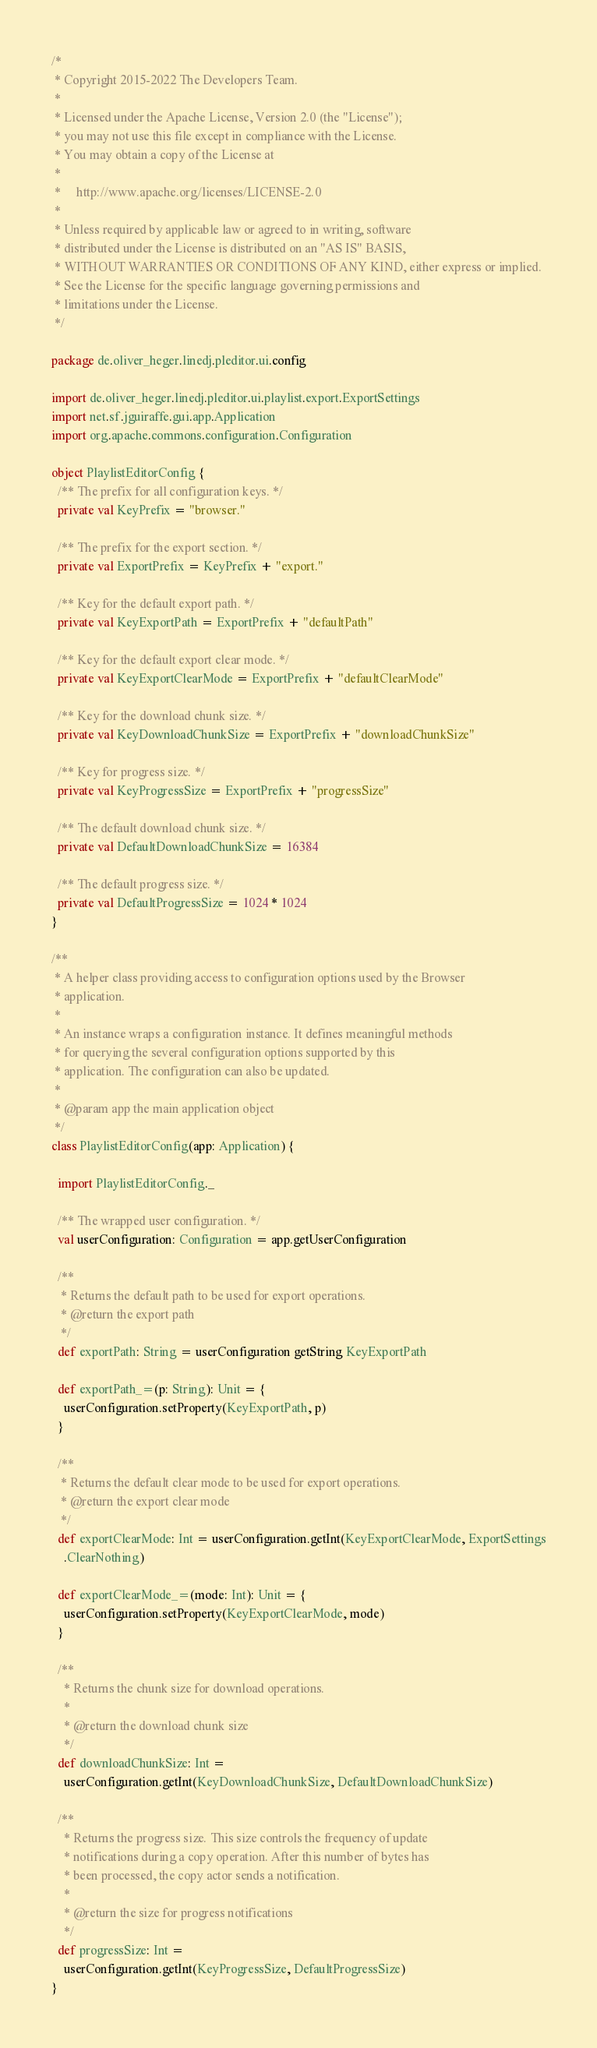<code> <loc_0><loc_0><loc_500><loc_500><_Scala_>/*
 * Copyright 2015-2022 The Developers Team.
 *
 * Licensed under the Apache License, Version 2.0 (the "License");
 * you may not use this file except in compliance with the License.
 * You may obtain a copy of the License at
 *
 *     http://www.apache.org/licenses/LICENSE-2.0
 *
 * Unless required by applicable law or agreed to in writing, software
 * distributed under the License is distributed on an "AS IS" BASIS,
 * WITHOUT WARRANTIES OR CONDITIONS OF ANY KIND, either express or implied.
 * See the License for the specific language governing permissions and
 * limitations under the License.
 */

package de.oliver_heger.linedj.pleditor.ui.config

import de.oliver_heger.linedj.pleditor.ui.playlist.export.ExportSettings
import net.sf.jguiraffe.gui.app.Application
import org.apache.commons.configuration.Configuration

object PlaylistEditorConfig {
  /** The prefix for all configuration keys. */
  private val KeyPrefix = "browser."

  /** The prefix for the export section. */
  private val ExportPrefix = KeyPrefix + "export."

  /** Key for the default export path. */
  private val KeyExportPath = ExportPrefix + "defaultPath"

  /** Key for the default export clear mode. */
  private val KeyExportClearMode = ExportPrefix + "defaultClearMode"

  /** Key for the download chunk size. */
  private val KeyDownloadChunkSize = ExportPrefix + "downloadChunkSize"

  /** Key for progress size. */
  private val KeyProgressSize = ExportPrefix + "progressSize"

  /** The default download chunk size. */
  private val DefaultDownloadChunkSize = 16384

  /** The default progress size. */
  private val DefaultProgressSize = 1024 * 1024
}

/**
 * A helper class providing access to configuration options used by the Browser
 * application.
 *
 * An instance wraps a configuration instance. It defines meaningful methods
 * for querying the several configuration options supported by this
 * application. The configuration can also be updated.
 *
 * @param app the main application object
 */
class PlaylistEditorConfig(app: Application) {

  import PlaylistEditorConfig._

  /** The wrapped user configuration. */
  val userConfiguration: Configuration = app.getUserConfiguration

  /**
   * Returns the default path to be used for export operations.
   * @return the export path
   */
  def exportPath: String = userConfiguration getString KeyExportPath

  def exportPath_=(p: String): Unit = {
    userConfiguration.setProperty(KeyExportPath, p)
  }

  /**
   * Returns the default clear mode to be used for export operations.
   * @return the export clear mode
   */
  def exportClearMode: Int = userConfiguration.getInt(KeyExportClearMode, ExportSettings
    .ClearNothing)

  def exportClearMode_=(mode: Int): Unit = {
    userConfiguration.setProperty(KeyExportClearMode, mode)
  }

  /**
    * Returns the chunk size for download operations.
    *
    * @return the download chunk size
    */
  def downloadChunkSize: Int =
    userConfiguration.getInt(KeyDownloadChunkSize, DefaultDownloadChunkSize)

  /**
    * Returns the progress size. This size controls the frequency of update
    * notifications during a copy operation. After this number of bytes has
    * been processed, the copy actor sends a notification.
    *
    * @return the size for progress notifications
    */
  def progressSize: Int =
    userConfiguration.getInt(KeyProgressSize, DefaultProgressSize)
}
</code> 